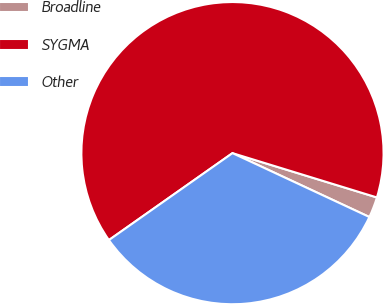<chart> <loc_0><loc_0><loc_500><loc_500><pie_chart><fcel>Broadline<fcel>SYGMA<fcel>Other<nl><fcel>2.21%<fcel>64.49%<fcel>33.29%<nl></chart> 